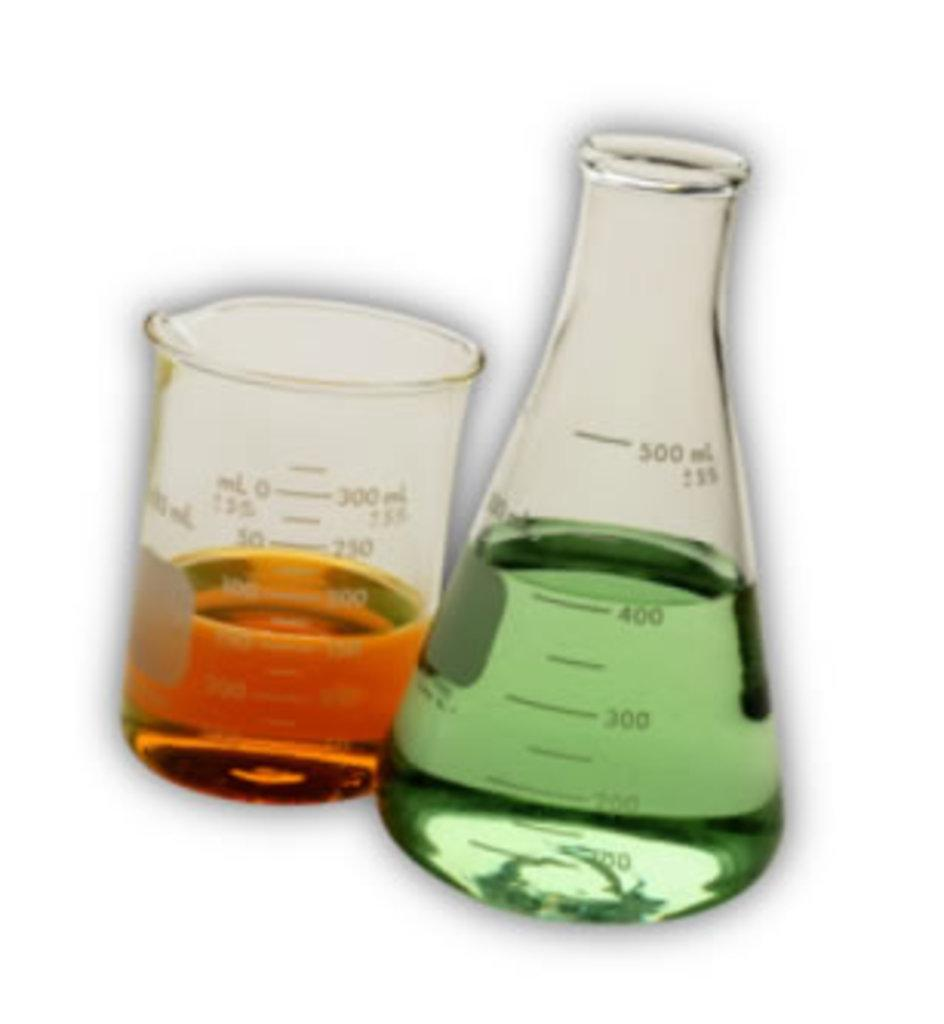<image>
Provide a brief description of the given image. two scientific measuring cups with a green liquid measuring 400 ML 